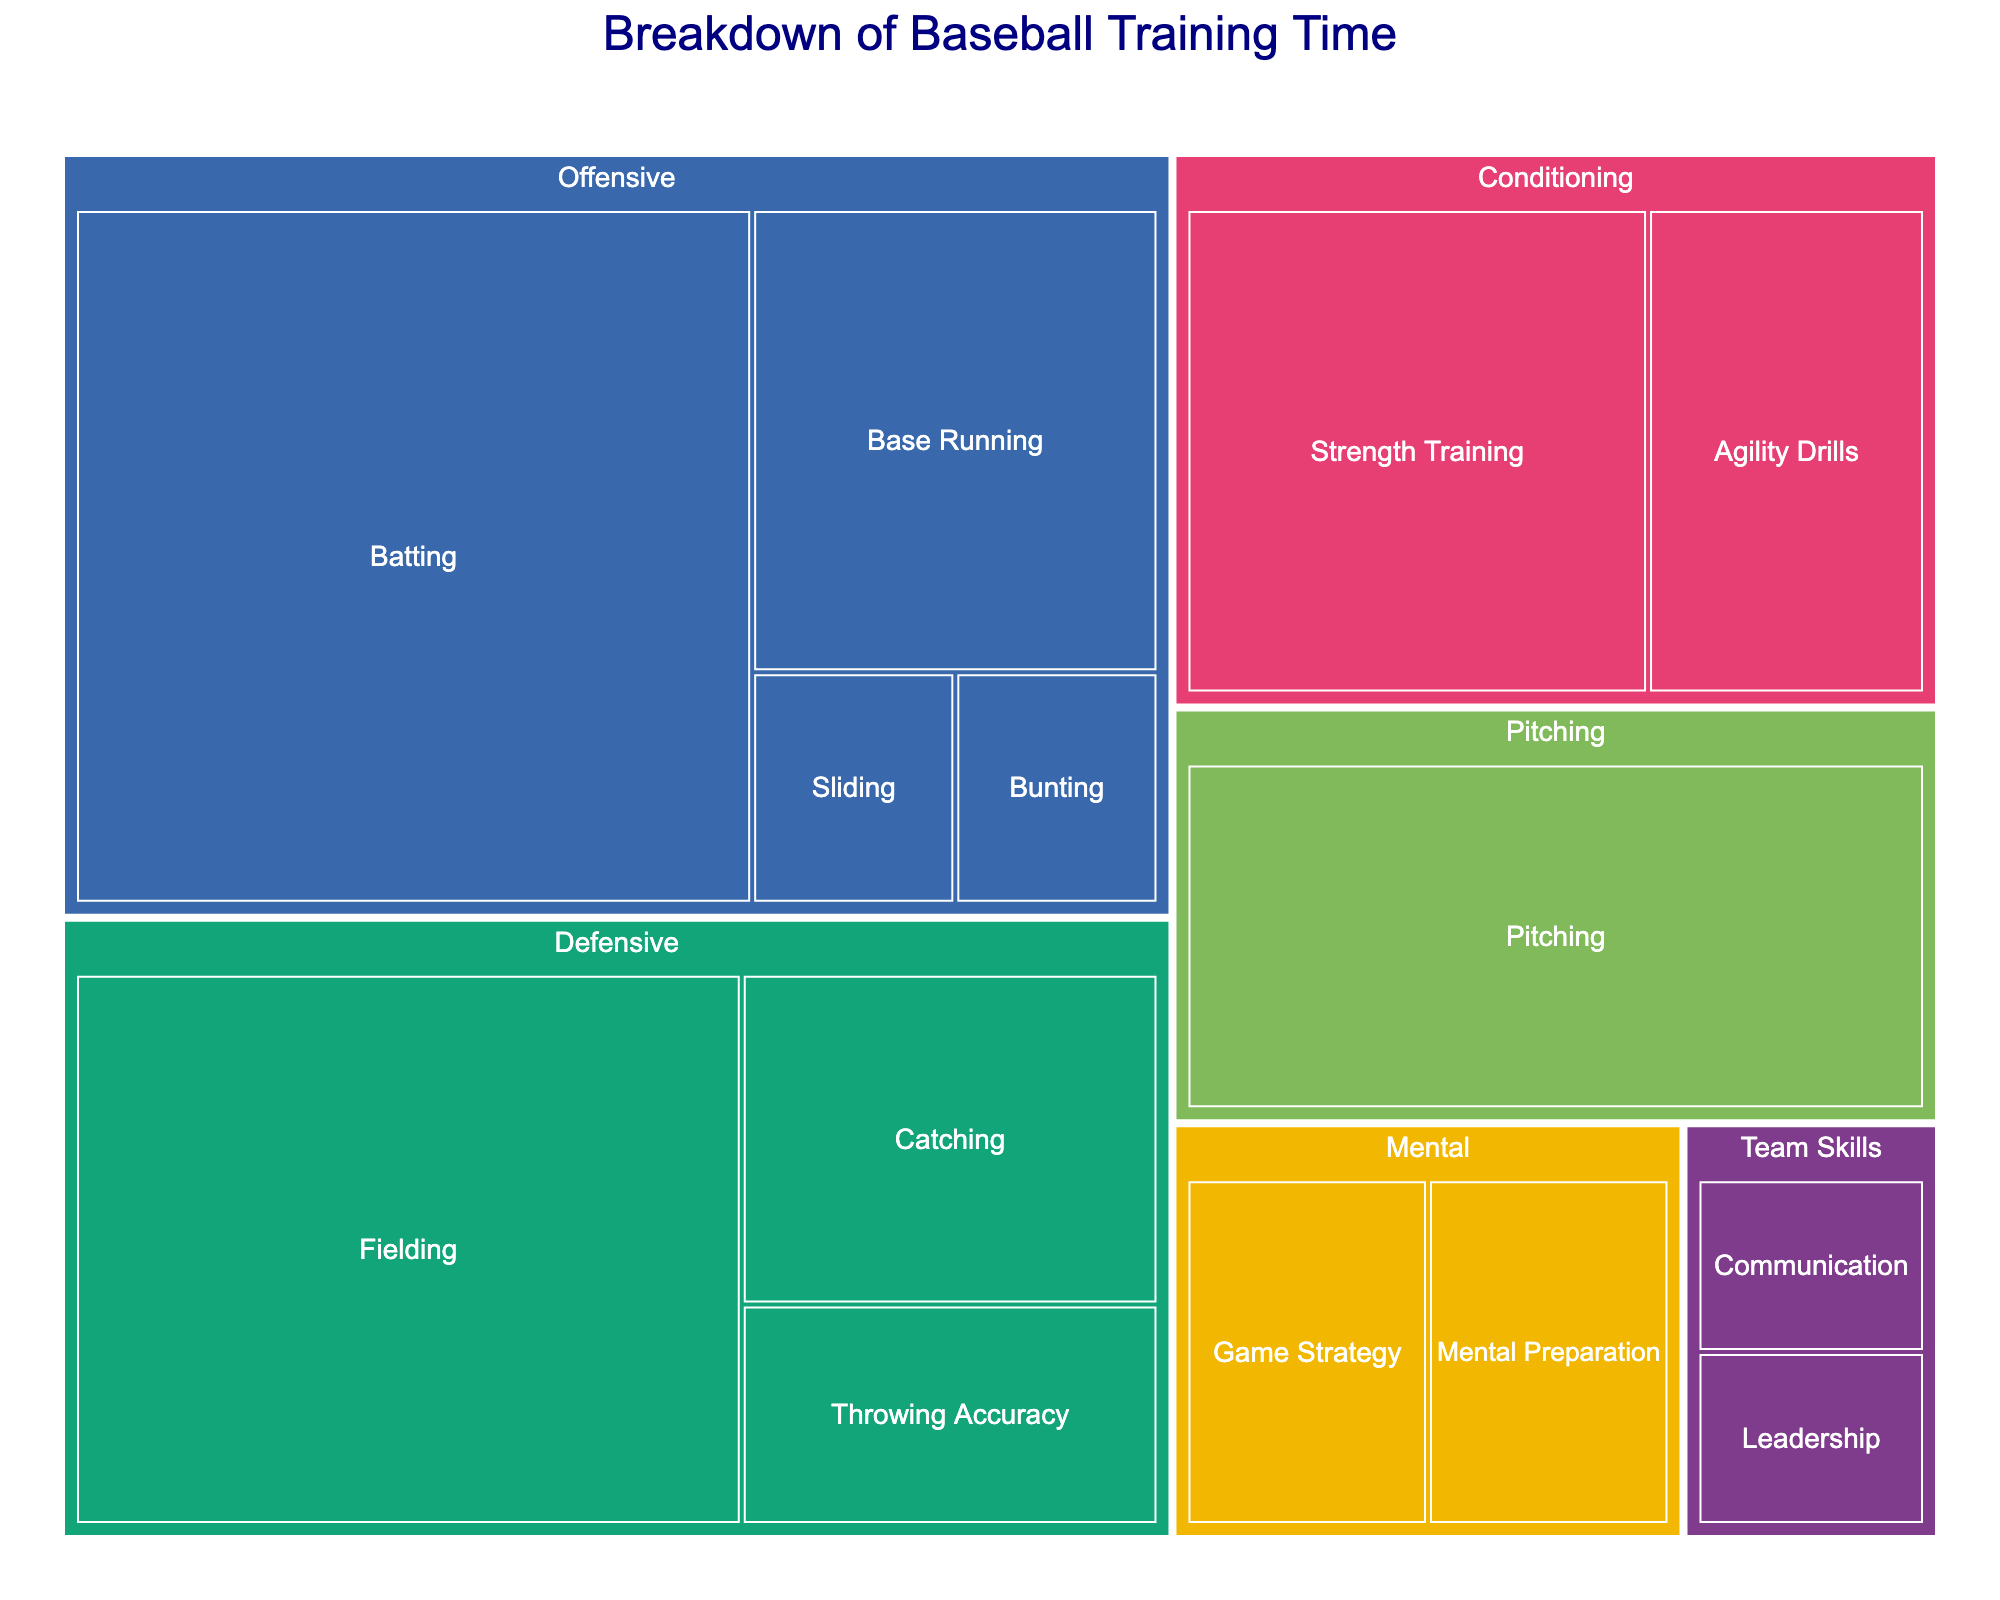what is the title of the figure? The title is displayed at the top of the figure in a larger font size compared to the other texts.
Answer: Breakdown of Baseball Training Time Which skill has the most training hours? The skill with the largest area in the treemap represents the skill with the most training hours.
Answer: Batting How many hours are dedicated to conditioning skills in total? Add the hours of all skills under the "Conditioning" category: Strength Training (25) + Agility Drills (15).
Answer: 40 What's the difference in training hours between Batting and Pitching? Batting has 50 hours and Pitching has 30 hours. Subtract the hours of Pitching from Batting: 50 - 30.
Answer: 20 Within the defensive category, which skill has fewer hours: Fielding or Catching? Compare the hours for Fielding (40) and Catching (15).
Answer: Catching How much more time is spent on Offensive skills compared to Team Skills? Sum of Offensive skills: Batting (50) + Base Running (20) + Bunting (5) + Sliding (5). Sum of Team Skills: Communication (5) + Leadership (5). Compare the sums: 80 - 10.
Answer: 70 What is the average training time for Mental skills? Sum of Mental preparation (10) and Game Strategy (10). Divide the sum by the number of skills: (10 + 10) / 2.
Answer: 10 Which category contains the most diverse set of skills? Count the unique skills in each category. The "Offensive" category has the most different skills listed (Batting, Base Running, Bunting, Sliding).
Answer: Offensive Which has more training hours: Defensive skills or Mental skills? Sum the hours of Defensive skills: Fielding (40) + Catching (15) + Throwing Accuracy (10). Sum the hours of Mental skills: Mental Preparation (10) + Game Strategy (10). Compare the sums: 65 > 20.
Answer: Defensive 